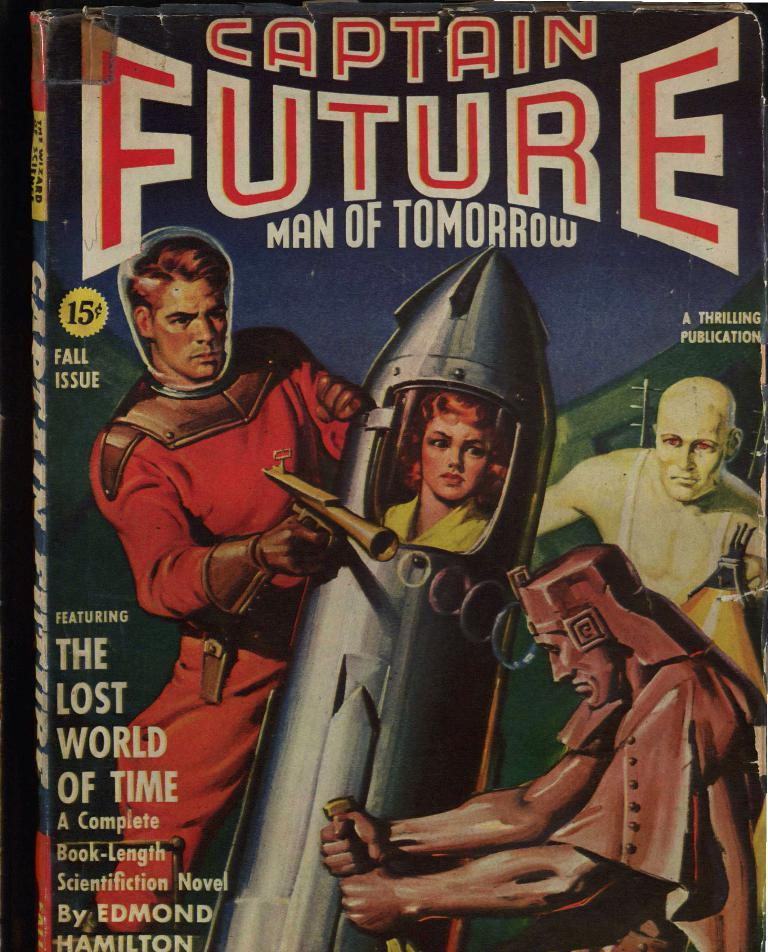<image>
Render a clear and concise summary of the photo. A magazine cover featuring Captain Future Man of Tomorrow shooting a ray gun. 